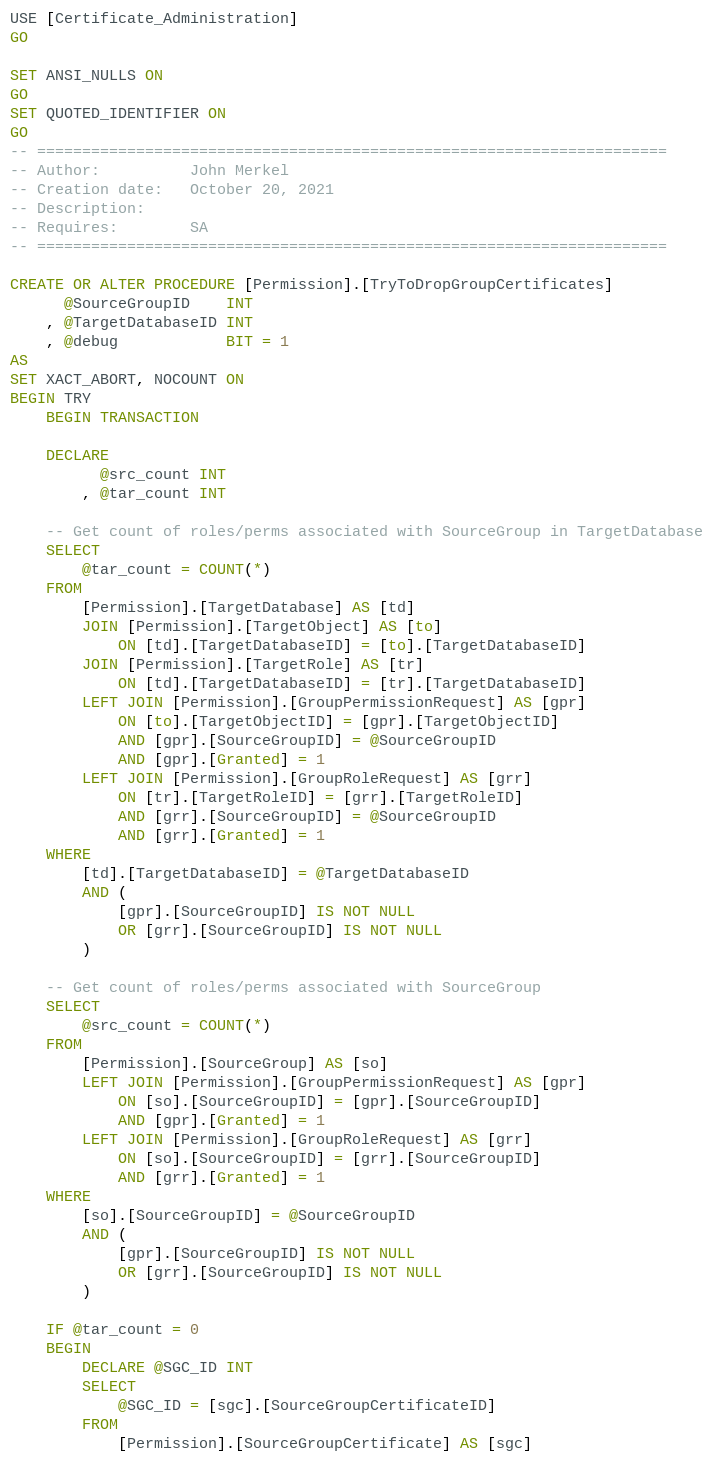<code> <loc_0><loc_0><loc_500><loc_500><_SQL_>USE [Certificate_Administration]
GO

SET ANSI_NULLS ON
GO
SET QUOTED_IDENTIFIER ON
GO
-- ======================================================================
-- Author:          John Merkel
-- Creation date:   October 20, 2021
-- Description:     
-- Requires:        SA
-- ======================================================================

CREATE OR ALTER PROCEDURE [Permission].[TryToDropGroupCertificates]
      @SourceGroupID    INT
    , @TargetDatabaseID INT
    , @debug            BIT = 1
AS
SET XACT_ABORT, NOCOUNT ON
BEGIN TRY
    BEGIN TRANSACTION

    DECLARE
          @src_count INT
        , @tar_count INT

    -- Get count of roles/perms associated with SourceGroup in TargetDatabase
    SELECT
        @tar_count = COUNT(*)
    FROM
        [Permission].[TargetDatabase] AS [td]
        JOIN [Permission].[TargetObject] AS [to]
            ON [td].[TargetDatabaseID] = [to].[TargetDatabaseID]
        JOIN [Permission].[TargetRole] AS [tr]
            ON [td].[TargetDatabaseID] = [tr].[TargetDatabaseID]
        LEFT JOIN [Permission].[GroupPermissionRequest] AS [gpr]
            ON [to].[TargetObjectID] = [gpr].[TargetObjectID]
            AND [gpr].[SourceGroupID] = @SourceGroupID
            AND [gpr].[Granted] = 1
        LEFT JOIN [Permission].[GroupRoleRequest] AS [grr]
            ON [tr].[TargetRoleID] = [grr].[TargetRoleID]
            AND [grr].[SourceGroupID] = @SourceGroupID
            AND [grr].[Granted] = 1
    WHERE
        [td].[TargetDatabaseID] = @TargetDatabaseID
        AND (
            [gpr].[SourceGroupID] IS NOT NULL
            OR [grr].[SourceGroupID] IS NOT NULL
        )

    -- Get count of roles/perms associated with SourceGroup
    SELECT
        @src_count = COUNT(*)
    FROM
        [Permission].[SourceGroup] AS [so]
        LEFT JOIN [Permission].[GroupPermissionRequest] AS [gpr]
            ON [so].[SourceGroupID] = [gpr].[SourceGroupID]
            AND [gpr].[Granted] = 1
        LEFT JOIN [Permission].[GroupRoleRequest] AS [grr]
            ON [so].[SourceGroupID] = [grr].[SourceGroupID]
            AND [grr].[Granted] = 1
    WHERE
        [so].[SourceGroupID] = @SourceGroupID
        AND (
            [gpr].[SourceGroupID] IS NOT NULL
            OR [grr].[SourceGroupID] IS NOT NULL
        )

    IF @tar_count = 0
    BEGIN
        DECLARE @SGC_ID INT
        SELECT
            @SGC_ID = [sgc].[SourceGroupCertificateID]
        FROM
            [Permission].[SourceGroupCertificate] AS [sgc]</code> 